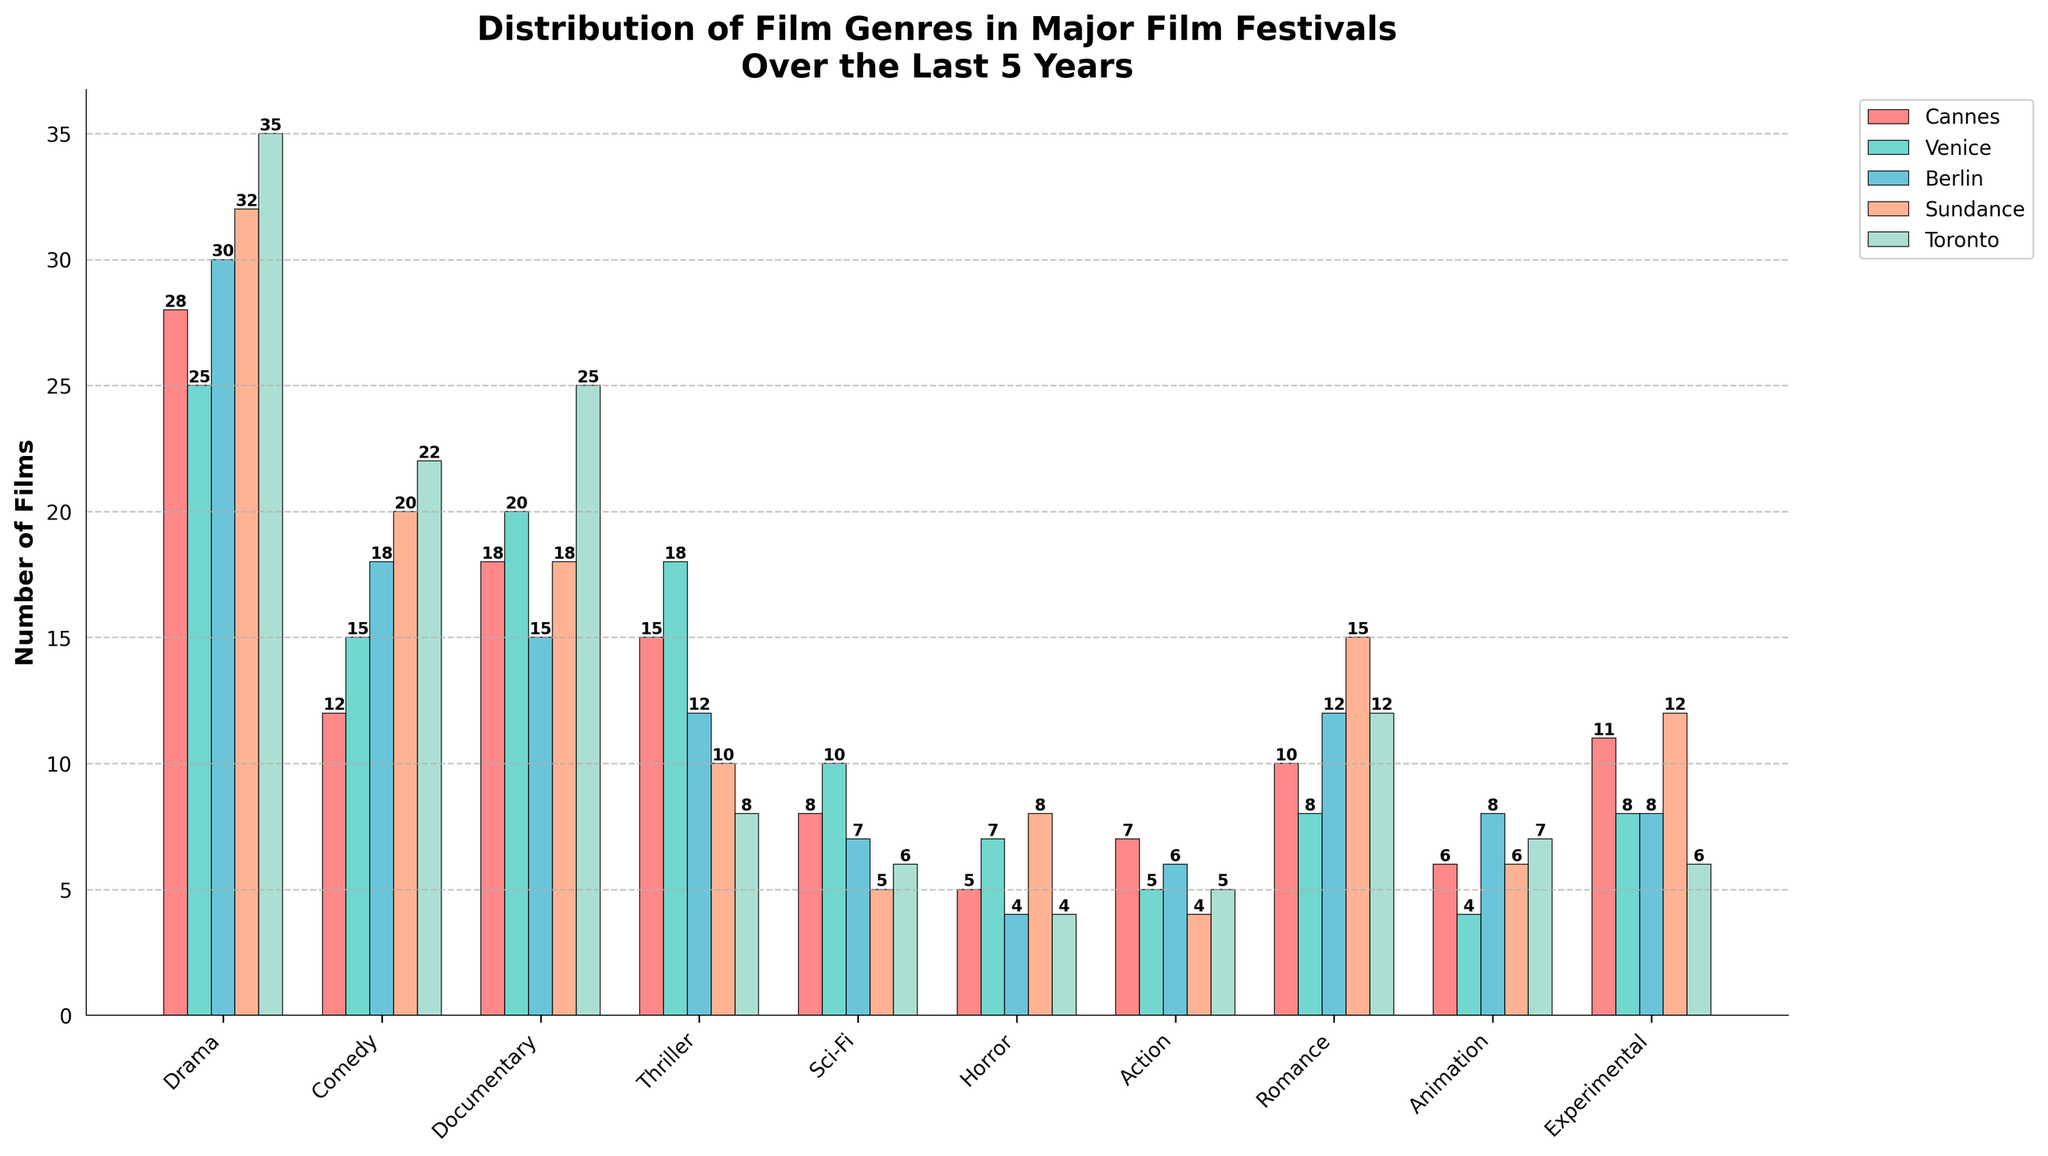What's the most common film genre at Sundance? Upon examining the bars in the chart, the tallest bar for Sundance is for Drama (32 films).
Answer: Drama Which genre has the lowest representation at Toronto? In Toronto, the shortest bar is for Horror with 4 films.
Answer: Horror What's the total number of Drama films in all festivals combined? The number of Drama films in Cannes (28) + Venice (25) + Berlin (30) + Sundance (32) + Toronto (35) is 150.
Answer: 150 How many more Comedy films are there at Toronto compared to Cannes? The number of Comedy films at Toronto is 22 and at Cannes is 12. The difference is 22 - 12 = 10.
Answer: 10 Is the number of Sci-Fi films greater at Venice or Berlin? The number of Sci-Fi films at Venice is 10 and at Berlin is 7.
Answer: Venice What is the combined number of Thriller films at Cannes and Venice? The number of Thriller films at Cannes (15) + Venice (18) is 33.
Answer: 33 Which festival has the highest number of Documentary films? By comparing the heights of the Documentary bars, Toronto has the highest number with 25 films.
Answer: Toronto Among all festivals, which genre's representation has the lowest number in Cannes? The genres in Cannes with their values are: Drama (28), Comedy (12), Documentary (18), Thriller (15), Sci-Fi (8), Horror (5), Action (7), Romance (10), Animation (6), and Experimental (11). The lowest number is for Horror with 5 films.
Answer: Horror What is the average number of Animation films across all festivals? The number of Animation films at Cannes (6) + Venice (4) + Berlin (8) + Sundance (6) + Toronto (7) is 31. The average is 31 / 5 = 6.2.
Answer: 6.2 